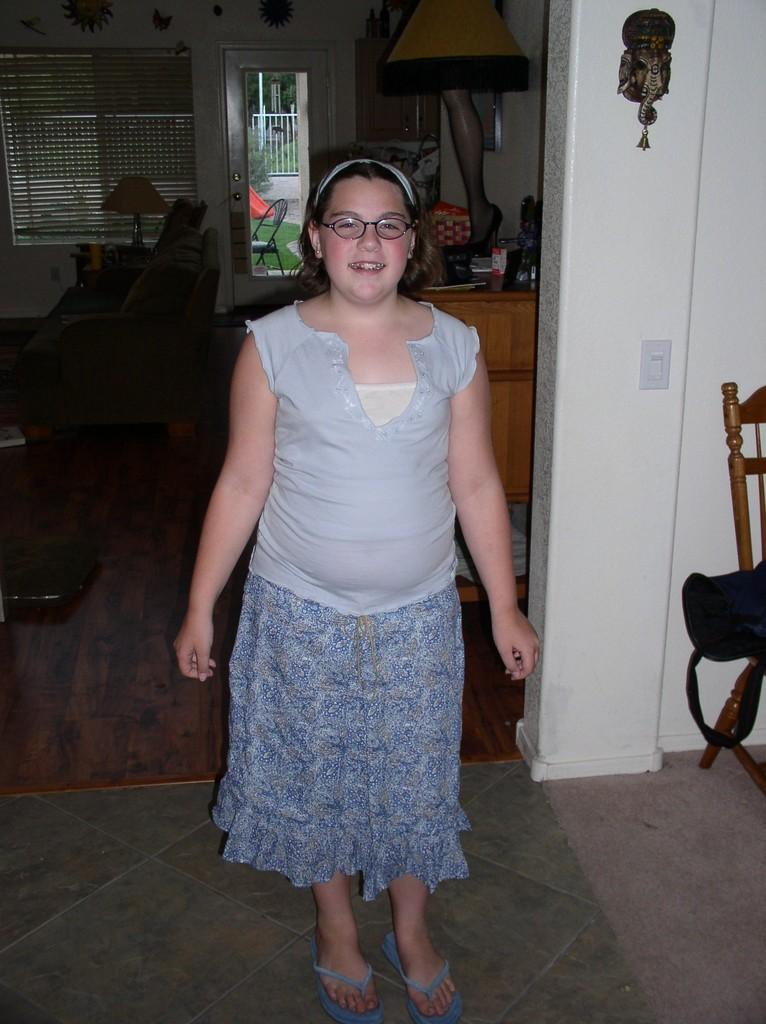Who is present in the image? There is a woman in the image. What is the woman doing in the image? The woman is standing and laughing. Can you describe the setting of the image? The image depicts a room. What furniture can be seen in the room? There is a sofa and chairs in the room. Are there any other objects in the room? Yes, there is a mirror and lamps in the room. What type of decorative items are present in the room? There are decorative items in the room. What type of zephyr can be seen blowing through the room in the image? There is no zephyr present in the image; it is a still image of a woman standing and laughing in a room. What kind of noise can be heard coming from the lamps in the image? The image is a still photograph, so no noise can be heard from the lamps or any other objects in the image. 